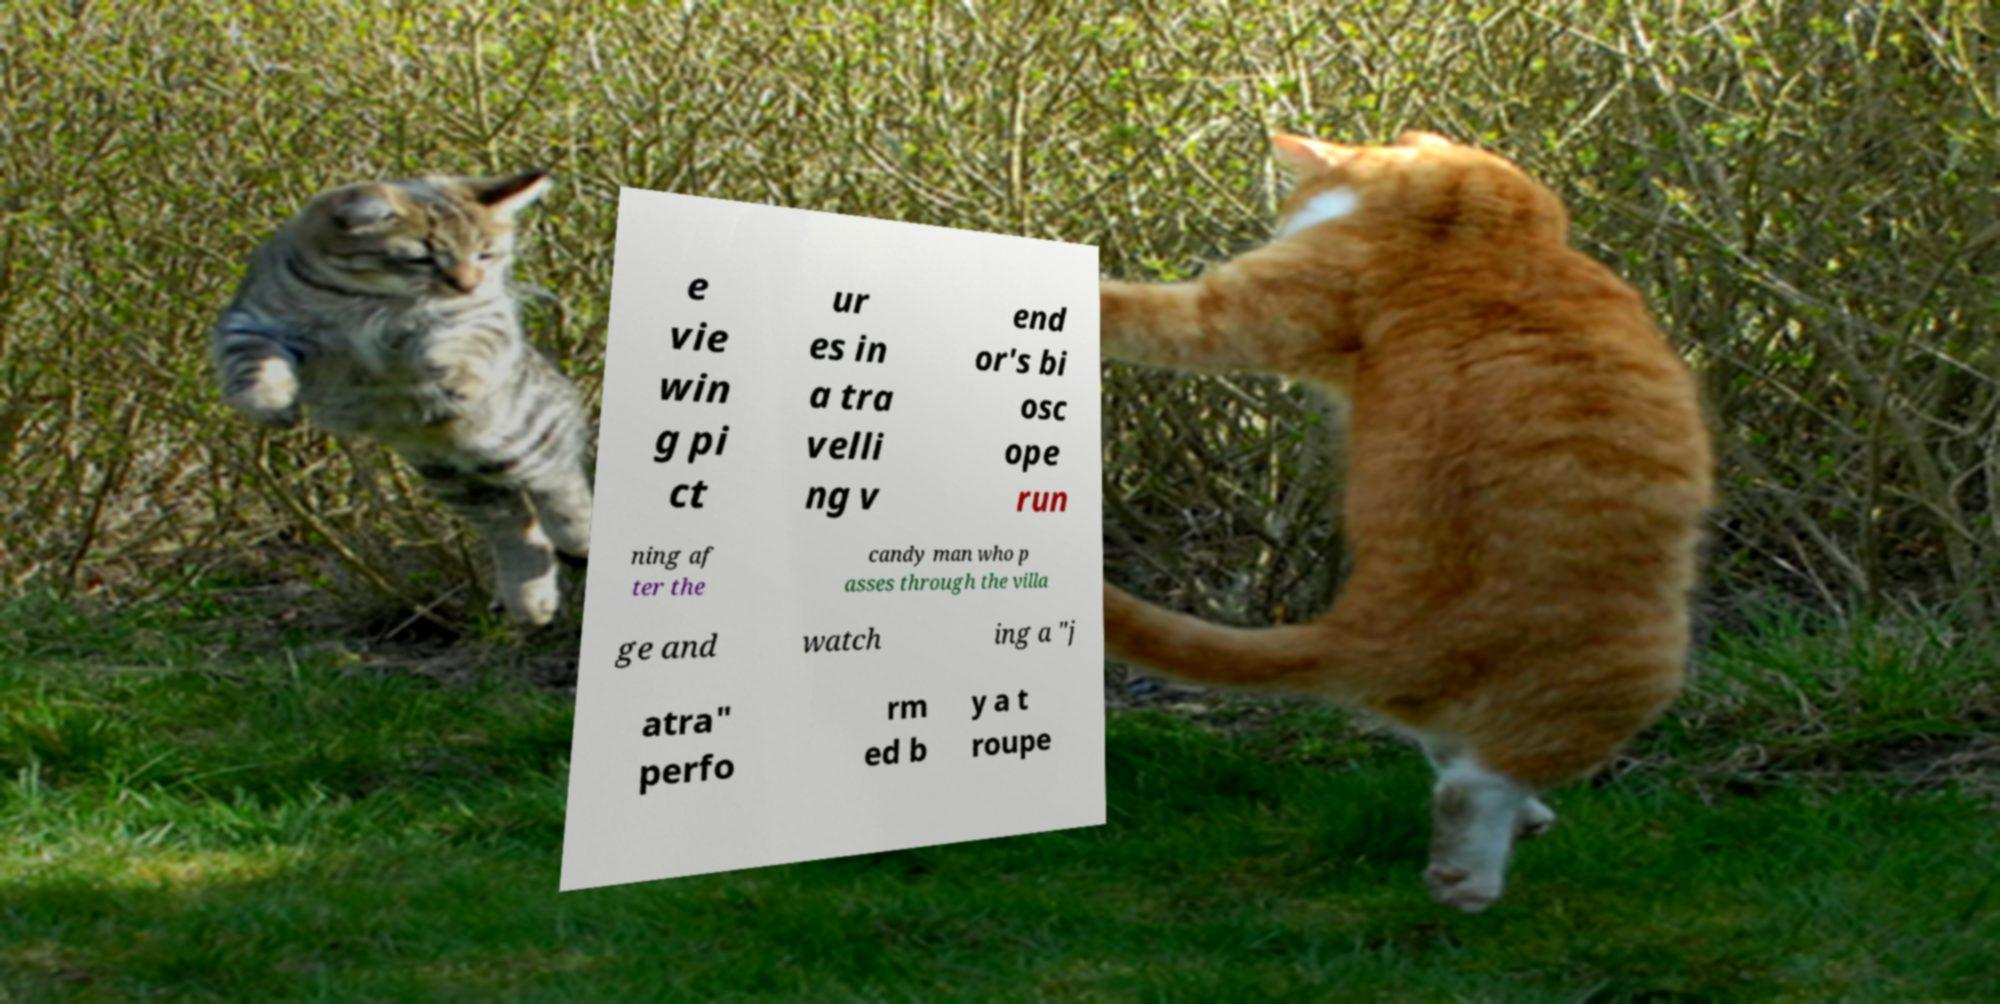Could you assist in decoding the text presented in this image and type it out clearly? e vie win g pi ct ur es in a tra velli ng v end or's bi osc ope run ning af ter the candy man who p asses through the villa ge and watch ing a "j atra" perfo rm ed b y a t roupe 